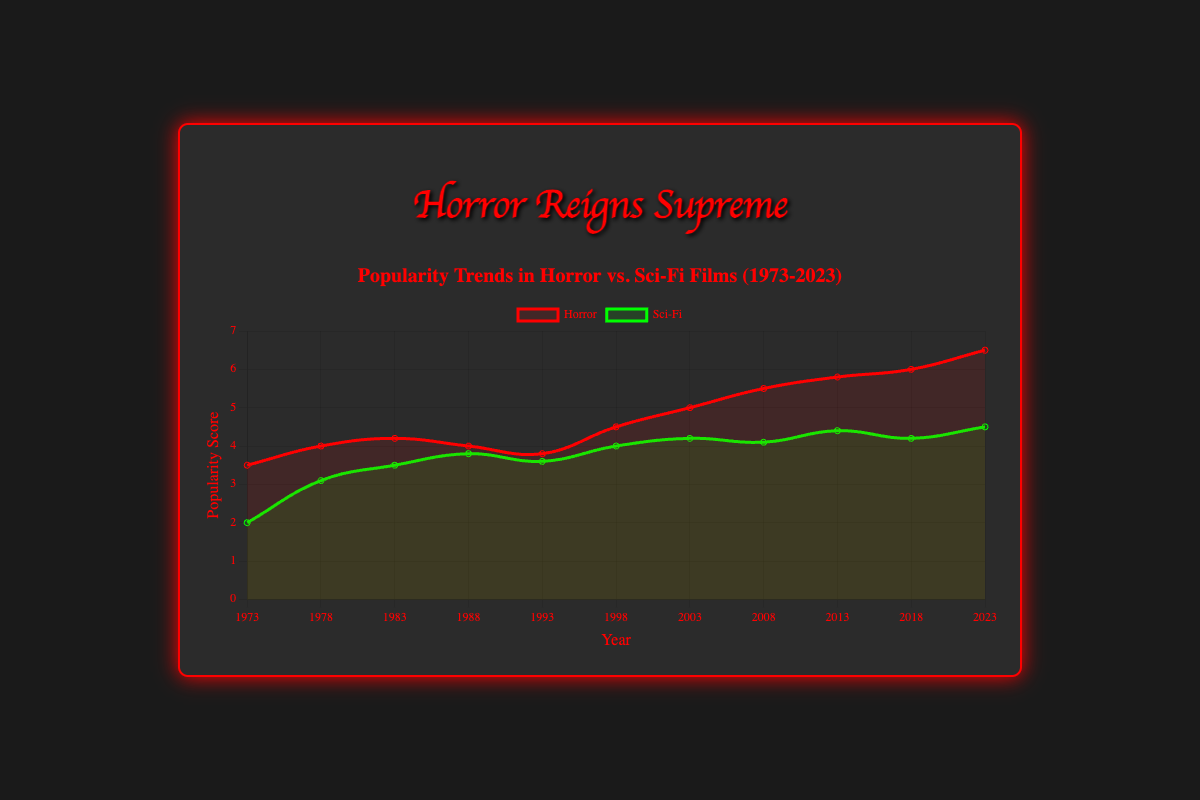Which genre had a higher popularity score in 1973? In 1973, the value for horror is 3.5, and for sci-fi, it is 2.0. According to the figure, horror had a higher popularity score that year.
Answer: Horror How did the popularity of horror films change from 2003 to 2023? In 2003, the popularity score for horror was 5.0. By 2023, it increased to 6.5. The change in popularity is calculated by subtracting the 2003 value from the 2023 value, 6.5 - 5.0 = 1.5.
Answer: Increased by 1.5 By how much did sci-fi films' popularity increase between 1978 and 1998? In 1978, the popularity of sci-fi films was 3.1. By 1998, it was 4.0. The increase is calculated by subtracting the 1978 value from the 1998 value, 4.0 - 3.1 = 0.9.
Answer: Increased by 0.9 During which year did horror films peak in popularity according to the figure? The highest value on the horror trend line is 6.5, which occurs in the year 2023. Therefore, horror films peaked in popularity in 2023.
Answer: 2023 Compared to horror films, which genre had a more consistent rise in popularity from 1973 to 2023? To determine consistency, the variance in the rise of popularity scores over the years must be considered. While both genres increased, horror has more fluctuations. Sci-fi's rise is more consistent, as it shows smaller incremental changes.
Answer: Sci-Fi What was the difference in popularity scores between horror and sci-fi films in 2018? In 2018, the popularity score for horror was 6.0 and for sci-fi, it was 4.2. The difference is calculated as 6.0 - 4.2 = 1.8.
Answer: 1.8 In which year did sci-fi films come closest to matching the popularity of horror films? Examining the values across the years, the smallest difference between the scores for horror and sci-fi films is observed in 1998, where the scores are 4.5 and 4.0 respectively, with a difference of 0.5.
Answer: 1998 How many times did horror films surpass a 5.0 popularity score from 1973 to 2023? By examining the data, horror films surpassed a 5.0 popularity score in 2008 (5.5), 2013 (5.8), 2018 (6.0), and 2023 (6.5). Thus, it happened four times.
Answer: 4 Which genre had the highest increase in popularity score in a single decade? Comparing all decades:
- Horror 1993 to 2003: 5.0 - 3.8 = 1.2
- Horror 2013 to 2023: 6.5 - 5.8 = 0.7
- Sci-Fi 1973 to 1983: 3.5 - 2.0 = 1.5
Sci-fi from 1973 to 1983 saw the biggest single decade rise of 1.5.
Answer: Sci-Fi 